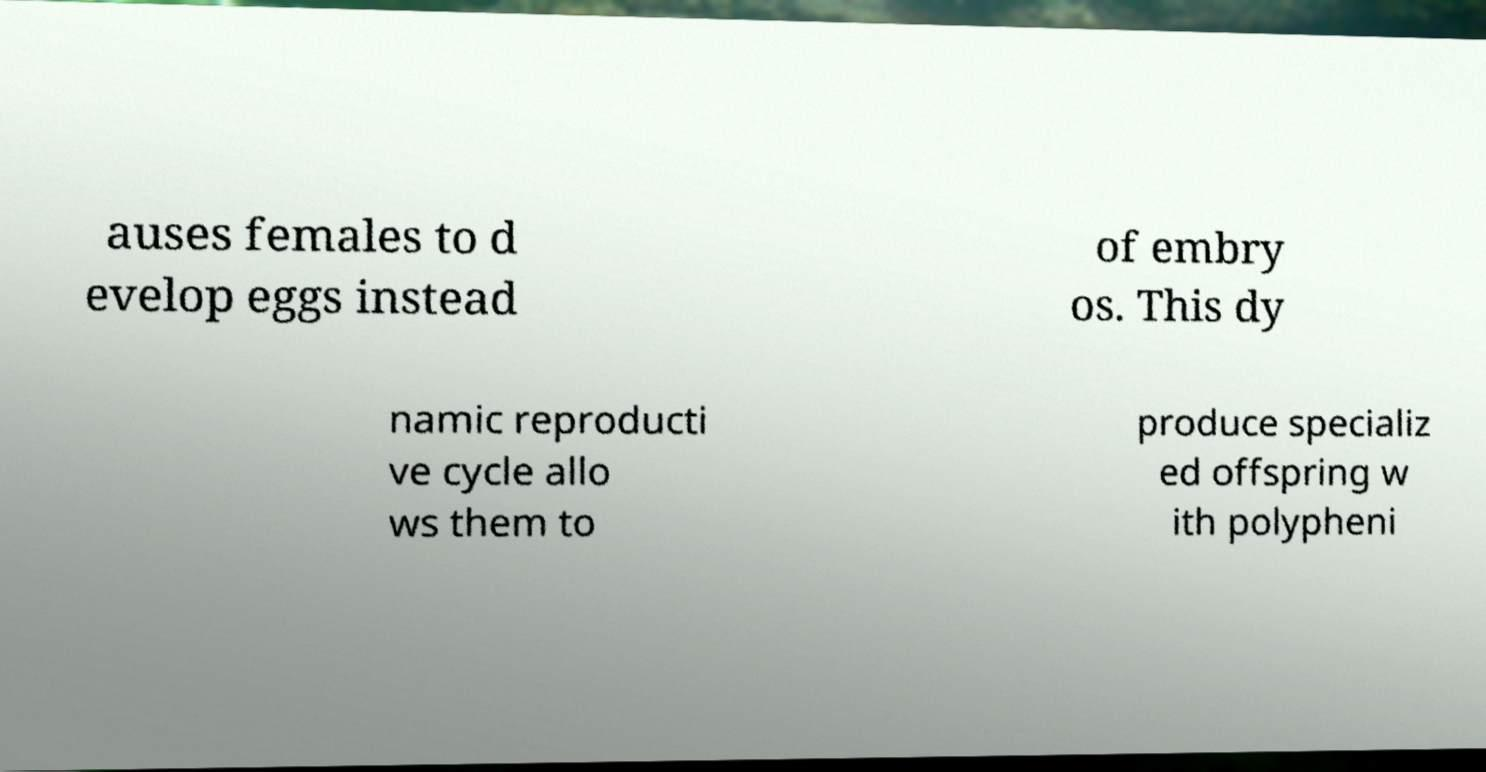Can you accurately transcribe the text from the provided image for me? auses females to d evelop eggs instead of embry os. This dy namic reproducti ve cycle allo ws them to produce specializ ed offspring w ith polypheni 